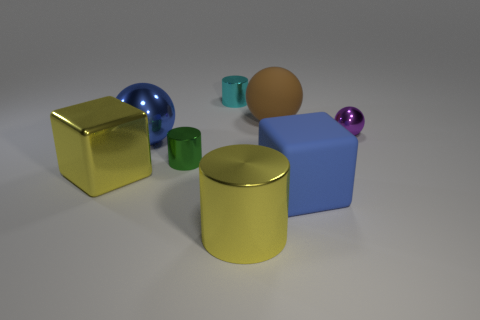Add 2 big blue metallic things. How many objects exist? 10 Subtract all yellow cylinders. How many cylinders are left? 2 Subtract all blocks. How many objects are left? 6 Subtract 1 cubes. How many cubes are left? 1 Subtract 1 brown spheres. How many objects are left? 7 Subtract all purple spheres. Subtract all yellow cubes. How many spheres are left? 2 Subtract all blue balls. Subtract all tiny red metal balls. How many objects are left? 7 Add 4 blue metallic things. How many blue metallic things are left? 5 Add 2 large rubber blocks. How many large rubber blocks exist? 3 Subtract all blue cubes. How many cubes are left? 1 